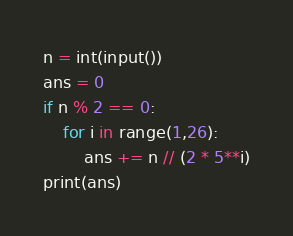<code> <loc_0><loc_0><loc_500><loc_500><_Python_>n = int(input())
ans = 0
if n % 2 == 0:
    for i in range(1,26):
        ans += n // (2 * 5**i)
print(ans)</code> 